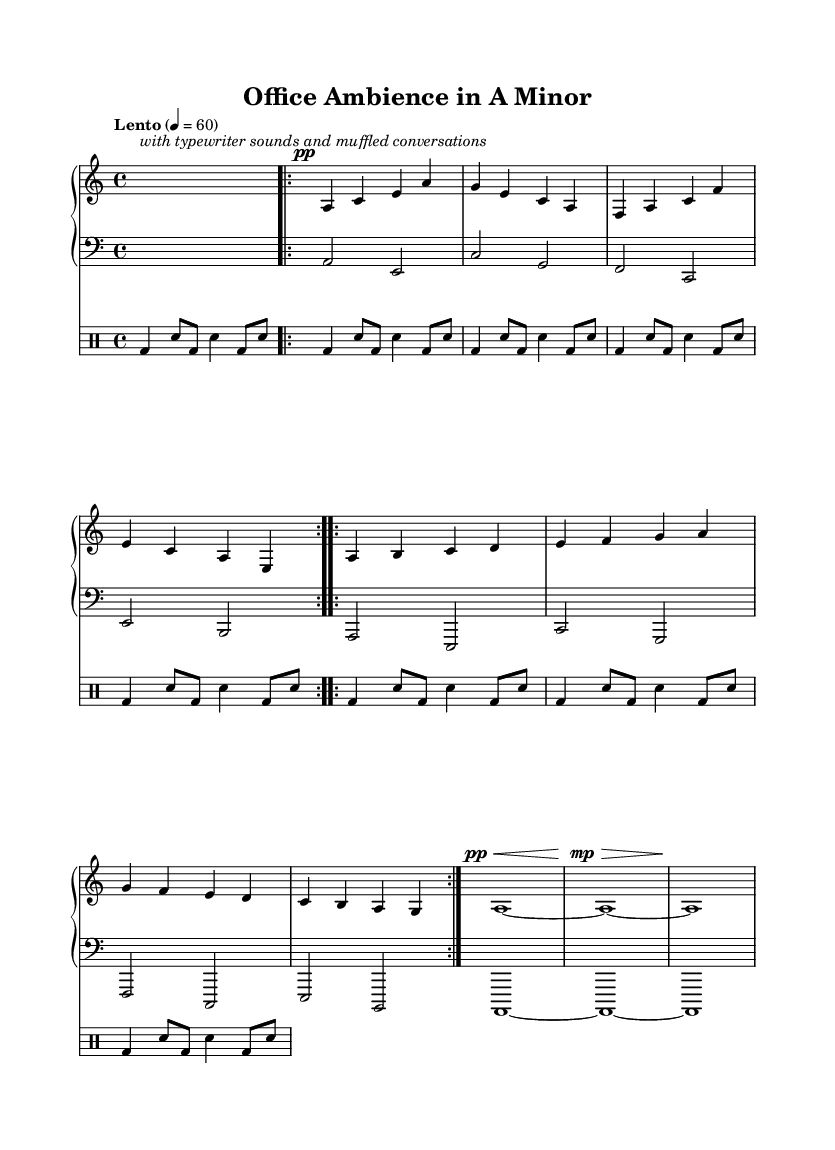What is the key signature of this music? The key signature is A minor, which is indicated by one sharp (G#) on the left side of the staff.
Answer: A minor What is the time signature of this music? The time signature is indicated right after the key signature, showing that there are four beats per measure in a 4/4 format.
Answer: 4/4 What is the tempo marking for this piece? The tempo marking states "Lento" with a metronome indication of 60 beats per minute, which is located at the beginning of the score.
Answer: Lento 4 = 60 How many times is the main theme repeated? The main theme is indicated by "volta" markers that specify it is repeated twice, which is found in the marked section of the score.
Answer: 2 What instruments are featured in this composition? The score lists two piano staves (right and left) and one drum staff for typewriter sounds, thus revealing the instrumentation used.
Answer: Piano and drums What unique sound elements are incorporated into this piece? The description in the intro explicitly mentions "typewriter sounds and muffled conversations," highlighting the experimental nature of the composition.
Answer: Typewriter sounds and muffled conversations How does the variation section differ from the main theme? Analyzing the notes in the variation section, they introduce different pitches and a different melodic progression compared to the repetitive sequence of the main theme.
Answer: Different pitches and melodic progression 